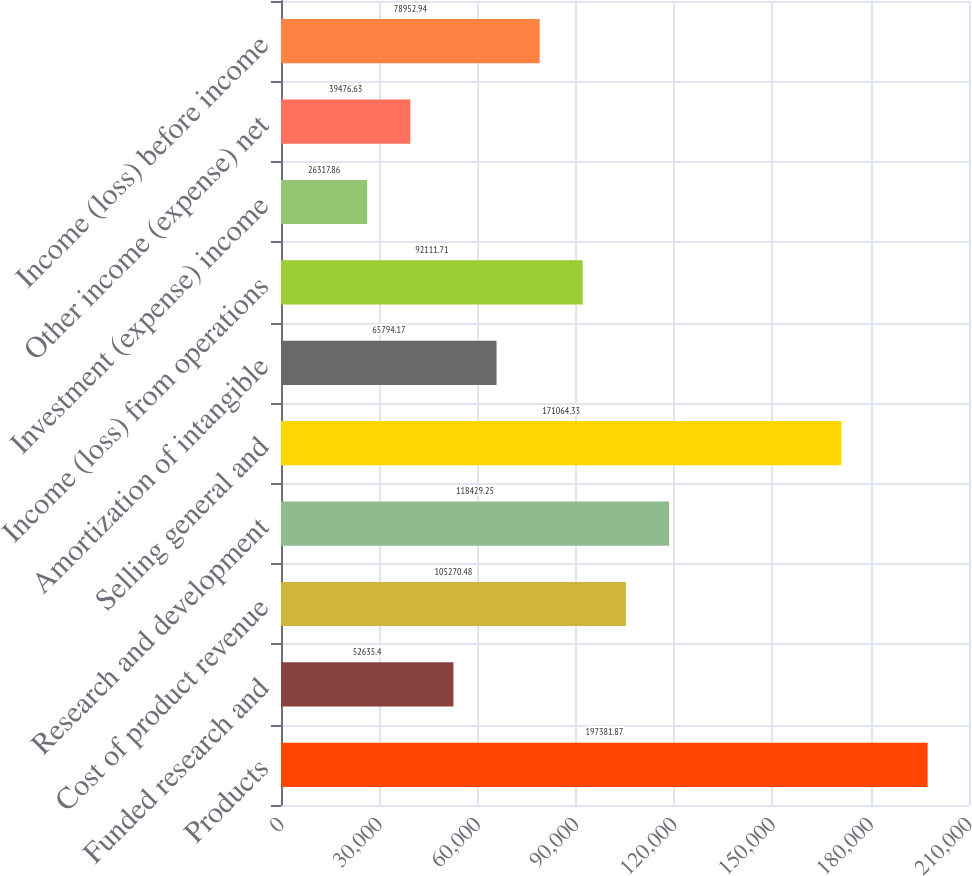Convert chart. <chart><loc_0><loc_0><loc_500><loc_500><bar_chart><fcel>Products<fcel>Funded research and<fcel>Cost of product revenue<fcel>Research and development<fcel>Selling general and<fcel>Amortization of intangible<fcel>Income (loss) from operations<fcel>Investment (expense) income<fcel>Other income (expense) net<fcel>Income (loss) before income<nl><fcel>197382<fcel>52635.4<fcel>105270<fcel>118429<fcel>171064<fcel>65794.2<fcel>92111.7<fcel>26317.9<fcel>39476.6<fcel>78952.9<nl></chart> 